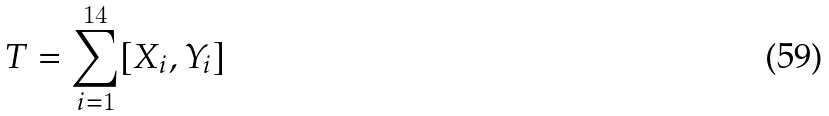Convert formula to latex. <formula><loc_0><loc_0><loc_500><loc_500>T = \sum _ { i = 1 } ^ { 1 4 } [ X _ { i } , Y _ { i } ]</formula> 